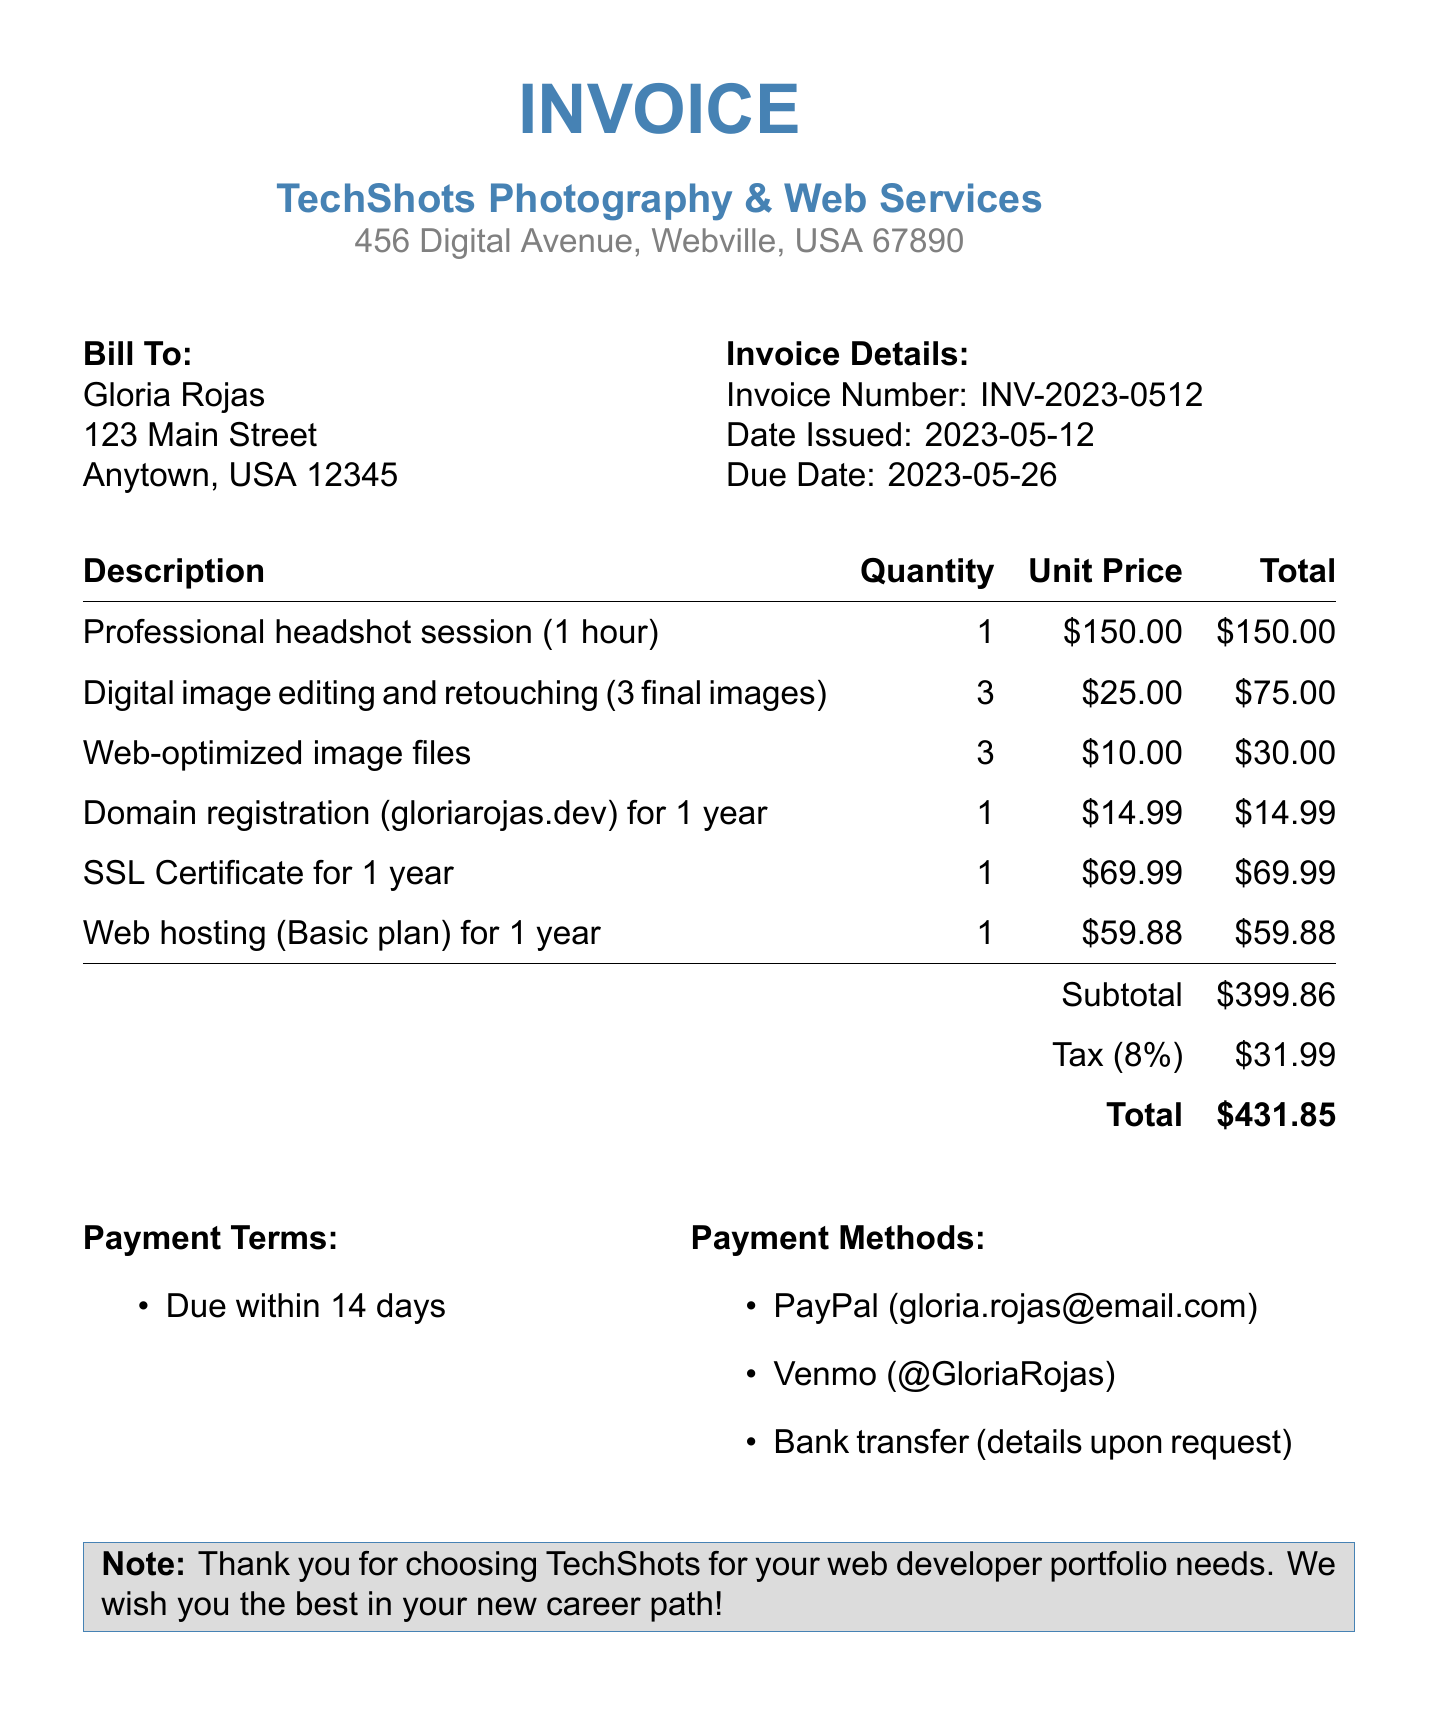What is the invoice number? The invoice number is listed as a unique identifier for the transaction.
Answer: INV-2023-0512 Who is the service provider? The service provider's name appears at the top of the document, indicating who issued the invoice.
Answer: TechShots Photography & Web Services What is the due date for the invoice? The due date specifies when the payment must be made, as detailed in the document.
Answer: 2023-05-26 How much is the subtotal before tax? The subtotal is listed separately from tax and represents the cost before tax is applied.
Answer: $399.86 What is the tax rate applied to the invoice? The tax rate indicates the percentage applied to the subtotal of the invoice to determine the tax amount.
Answer: 8% What is the total amount due? The total amount is the final sum of the subtotal and tax, as detailed in the document.
Answer: $431.85 What is the payment term stated in the invoice? The payment term specifies the conditions under which the payment is expected to be made.
Answer: Due within 14 days How many final images were edited and retouched? The number of final images indicates how many images underwent editing and retouching as part of the service.
Answer: 3 What service is provided under the domain registration? The domain registration indicates a specific service related to securing a website address for a year.
Answer: gloriarojas.dev What payment methods are accepted? The payment methods provide options for how the invoice can be paid, as listed in the document.
Answer: PayPal, Venmo, Bank transfer 